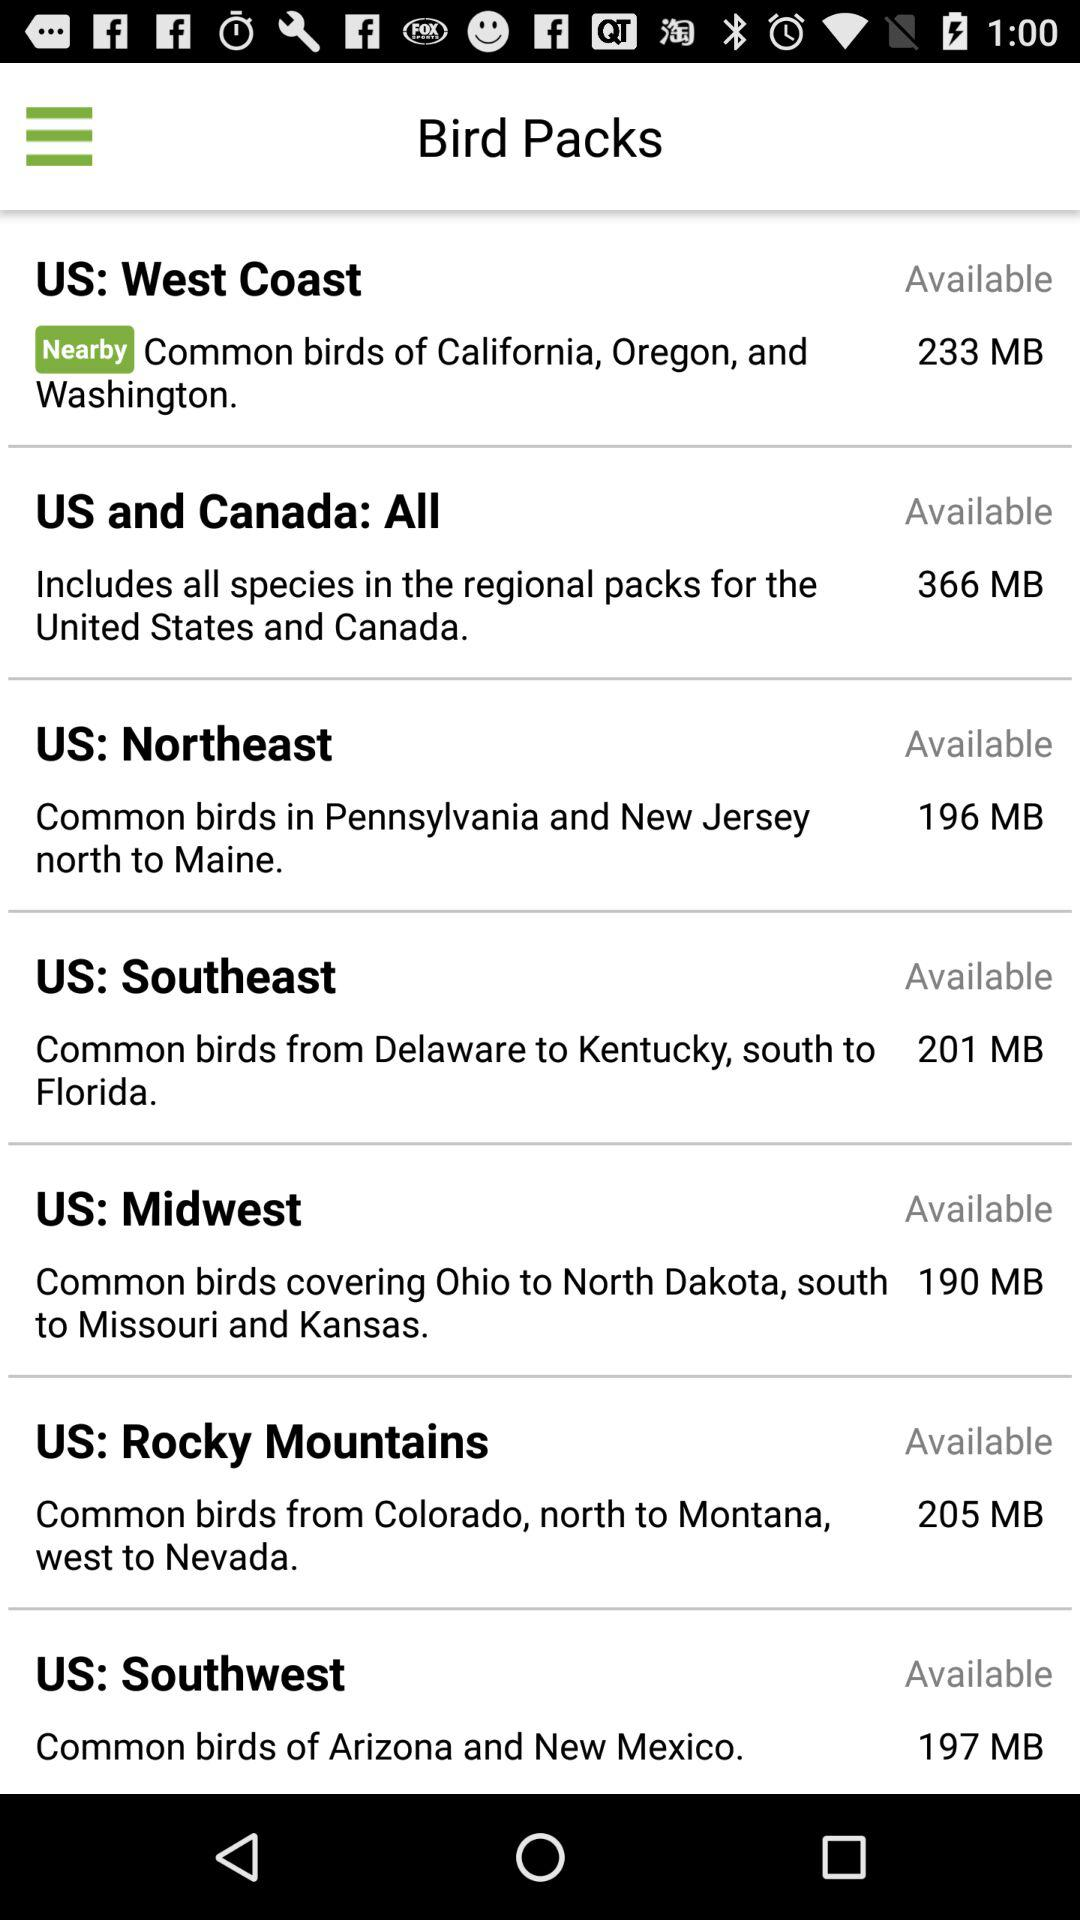How many MB are required for the "US: West Coast" bird pack? The required number of MB is 233. 